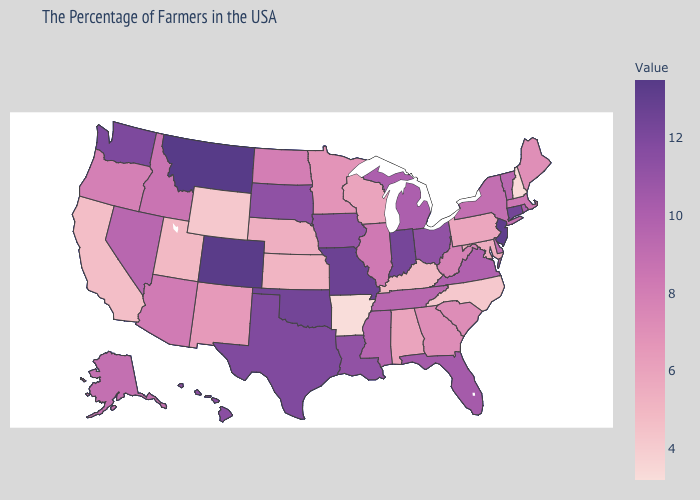Does Kansas have a higher value than Arkansas?
Give a very brief answer. Yes. Which states hav the highest value in the Northeast?
Keep it brief. New Jersey. Among the states that border Connecticut , which have the lowest value?
Give a very brief answer. Massachusetts. Does the map have missing data?
Answer briefly. No. Among the states that border Georgia , does Florida have the highest value?
Write a very short answer. Yes. 